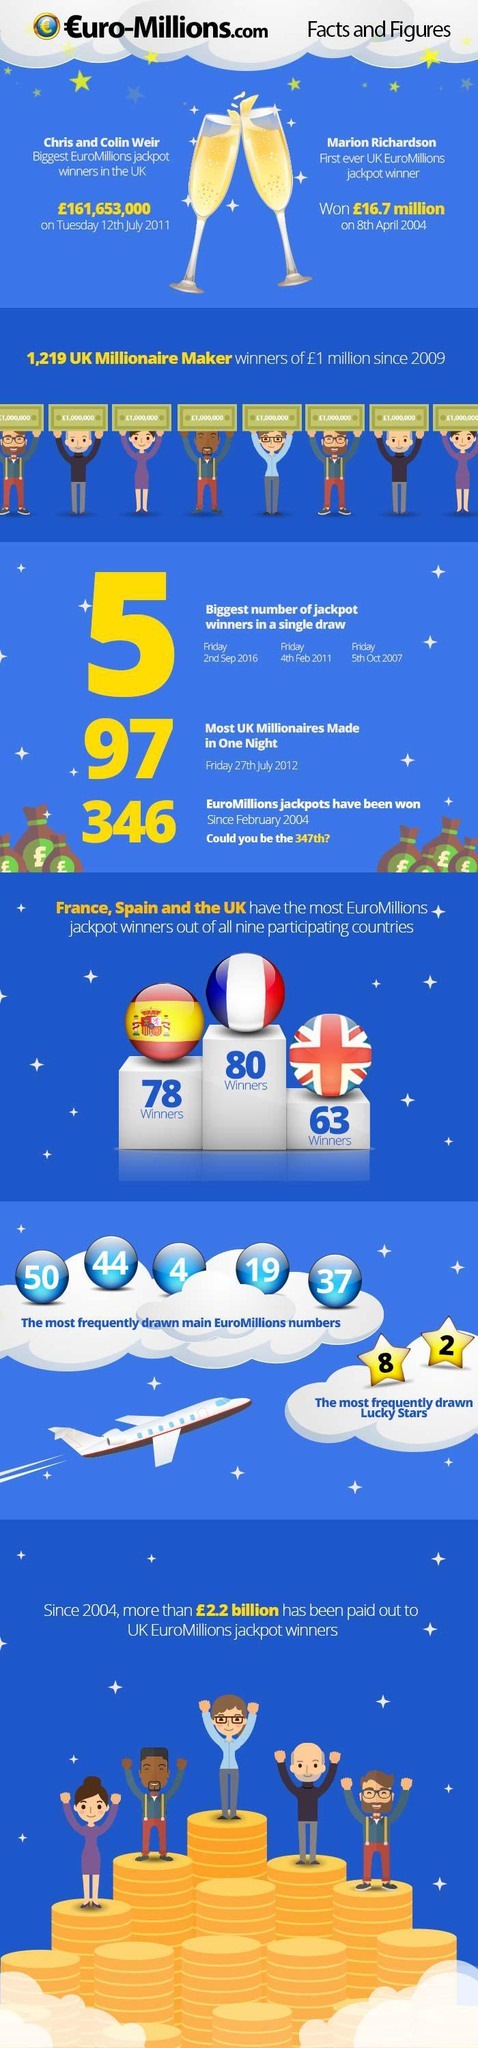Which country has the highest number Euromillion jackpot winners?
Answer the question with a short phrase. France Which country gets the second place in having the most Euromillions jackpot winners? Spain Which country has the lowest Euromillion jackpot winner between UK, France, or Spain? UK Which among the following is not a lucky star number 4, 8, or 2? 4 Which number is not among the most frequently drawn main EuroMillions numbers 50, 44, 4, 38, or 37? 38 